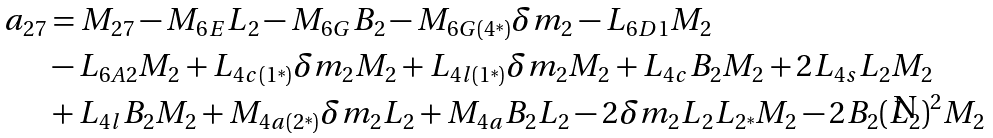Convert formula to latex. <formula><loc_0><loc_0><loc_500><loc_500>a _ { 2 7 } & = M _ { 2 7 } - M _ { 6 E } L _ { 2 } - M _ { 6 G } B _ { 2 } - M _ { 6 G ( 4 ^ { \ast } ) } \delta m _ { 2 } - L _ { 6 D 1 } M _ { 2 } \\ & - L _ { 6 A 2 } M _ { 2 } + L _ { 4 c ( 1 ^ { \ast } ) } \delta m _ { 2 } M _ { 2 } + L _ { 4 l ( 1 ^ { \ast } ) } \delta m _ { 2 } M _ { 2 } + L _ { 4 c } B _ { 2 } M _ { 2 } + 2 L _ { 4 s } L _ { 2 } M _ { 2 } \\ & + L _ { 4 l } B _ { 2 } M _ { 2 } + M _ { 4 a ( 2 ^ { \ast } ) } \delta m _ { 2 } L _ { 2 } + M _ { 4 a } B _ { 2 } L _ { 2 } - 2 \delta m _ { 2 } L _ { 2 } L _ { 2 ^ { \ast } } M _ { 2 } - 2 B _ { 2 } ( L _ { 2 } ) ^ { 2 } M _ { 2 }</formula> 